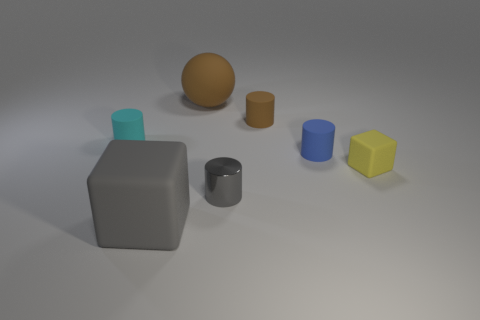There is a small gray thing that is the same shape as the small brown rubber object; what is it made of?
Give a very brief answer. Metal. There is a brown ball that is made of the same material as the tiny yellow cube; what is its size?
Keep it short and to the point. Large. There is a rubber object in front of the tiny yellow block; what is its size?
Your answer should be compact. Large. What size is the metal cylinder that is the same color as the large cube?
Your response must be concise. Small. Are there any tiny metal cylinders that have the same color as the large matte cube?
Keep it short and to the point. Yes. Is the color of the tiny metal cylinder the same as the block to the left of the blue rubber cylinder?
Offer a terse response. Yes. There is a small cylinder that is in front of the small blue thing; what is its material?
Your answer should be very brief. Metal. Is there a tiny gray ball?
Offer a terse response. No. There is a tiny metallic object that is the same shape as the blue rubber object; what is its color?
Make the answer very short. Gray. There is a big thing that is in front of the tiny brown rubber thing; is it the same color as the tiny metallic thing?
Your answer should be very brief. Yes. 